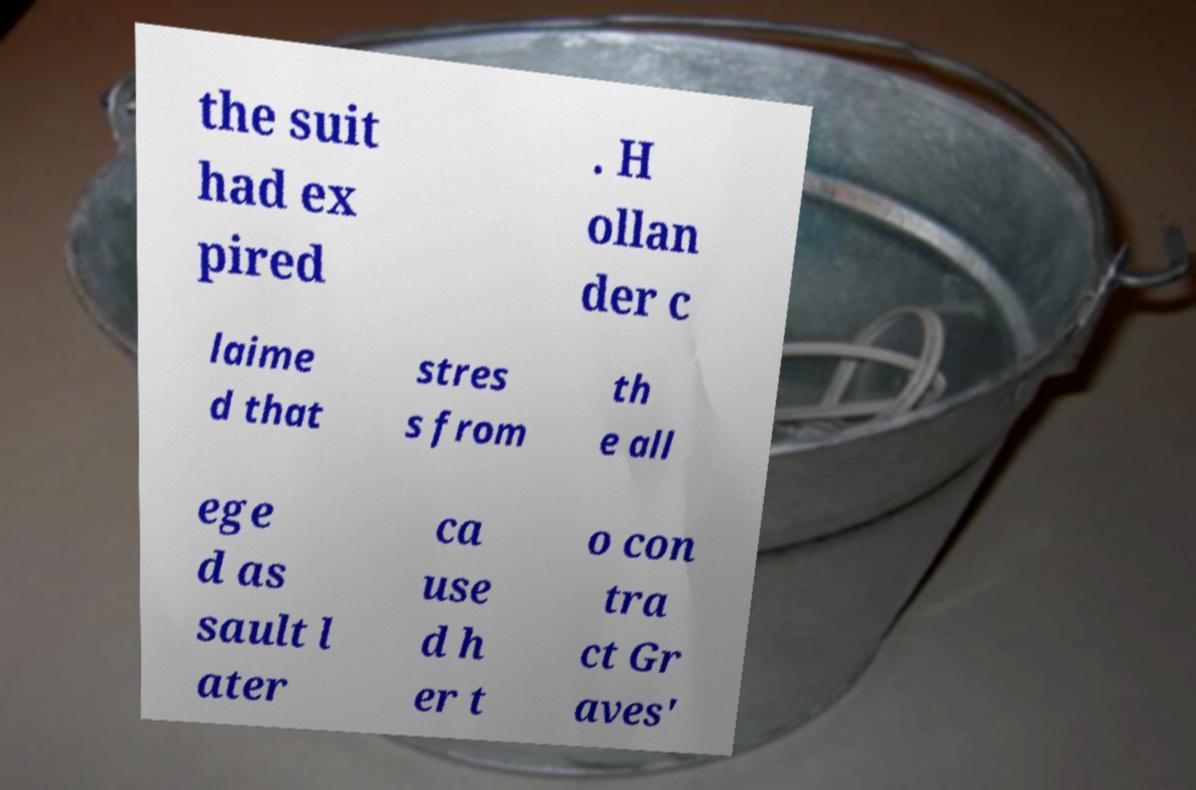Can you accurately transcribe the text from the provided image for me? the suit had ex pired . H ollan der c laime d that stres s from th e all ege d as sault l ater ca use d h er t o con tra ct Gr aves' 